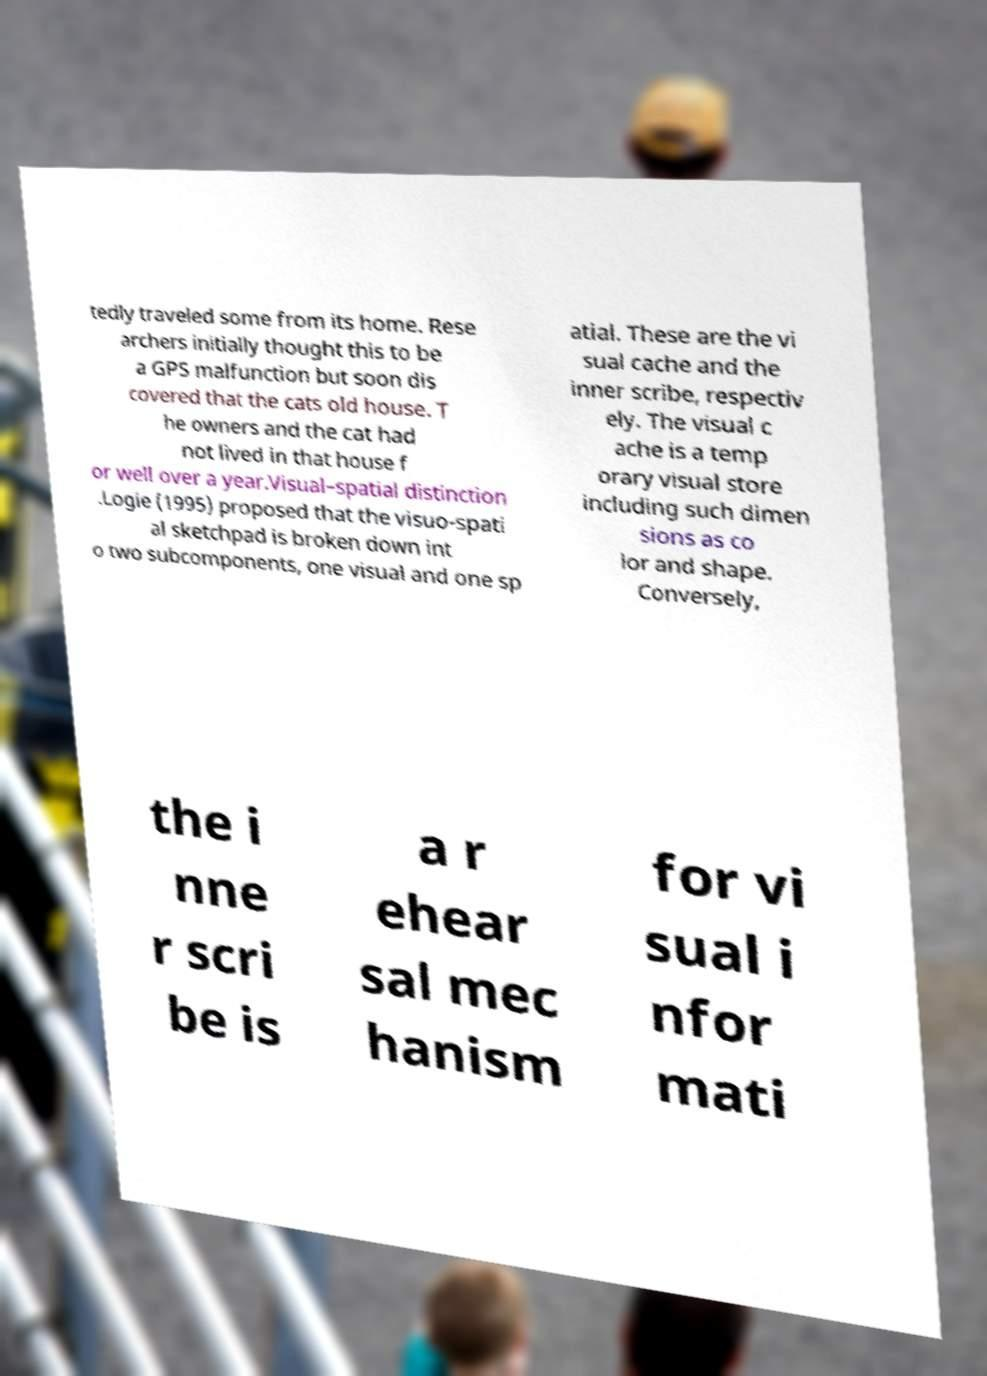What messages or text are displayed in this image? I need them in a readable, typed format. tedly traveled some from its home. Rese archers initially thought this to be a GPS malfunction but soon dis covered that the cats old house. T he owners and the cat had not lived in that house f or well over a year.Visual–spatial distinction .Logie (1995) proposed that the visuo-spati al sketchpad is broken down int o two subcomponents, one visual and one sp atial. These are the vi sual cache and the inner scribe, respectiv ely. The visual c ache is a temp orary visual store including such dimen sions as co lor and shape. Conversely, the i nne r scri be is a r ehear sal mec hanism for vi sual i nfor mati 